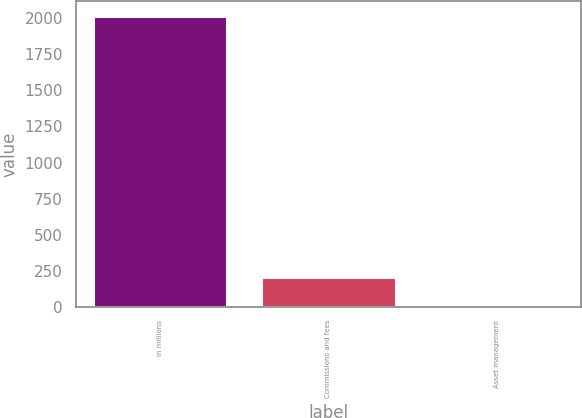<chart> <loc_0><loc_0><loc_500><loc_500><bar_chart><fcel>in millions<fcel>Commissions and fees<fcel>Asset management<nl><fcel>2016<fcel>205.2<fcel>4<nl></chart> 